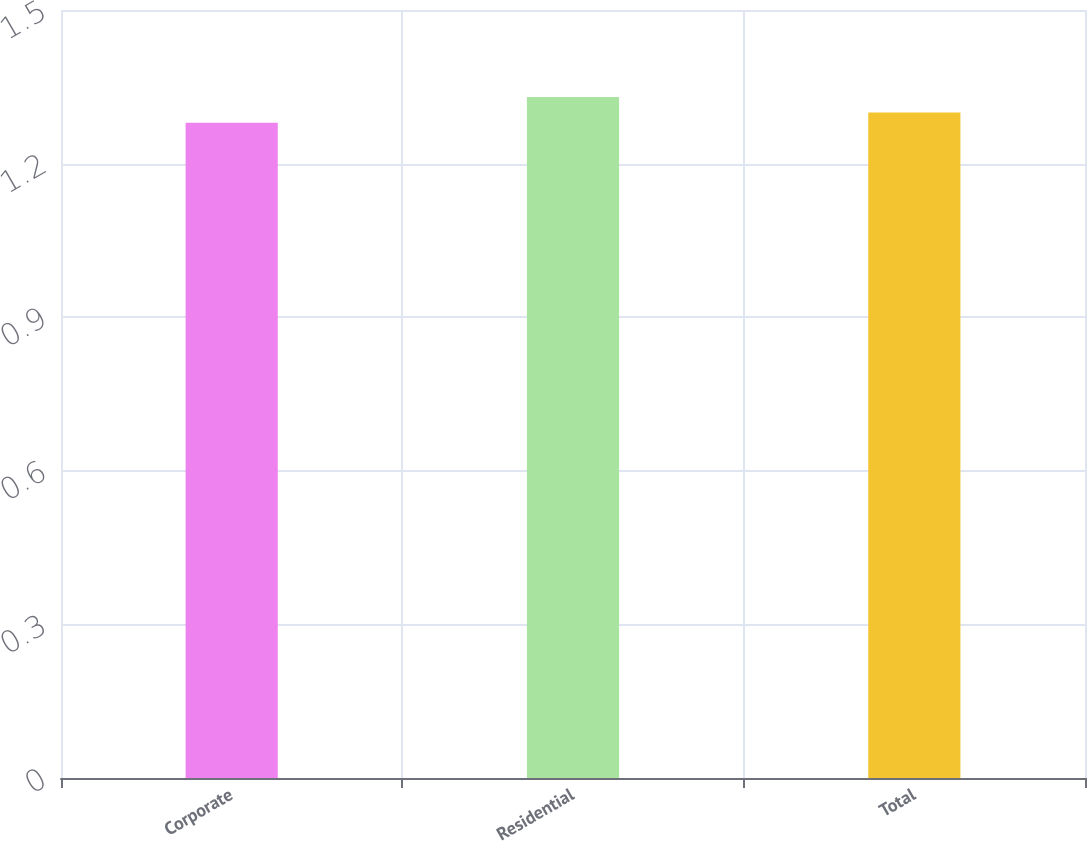Convert chart. <chart><loc_0><loc_0><loc_500><loc_500><bar_chart><fcel>Corporate<fcel>Residential<fcel>Total<nl><fcel>1.28<fcel>1.33<fcel>1.3<nl></chart> 